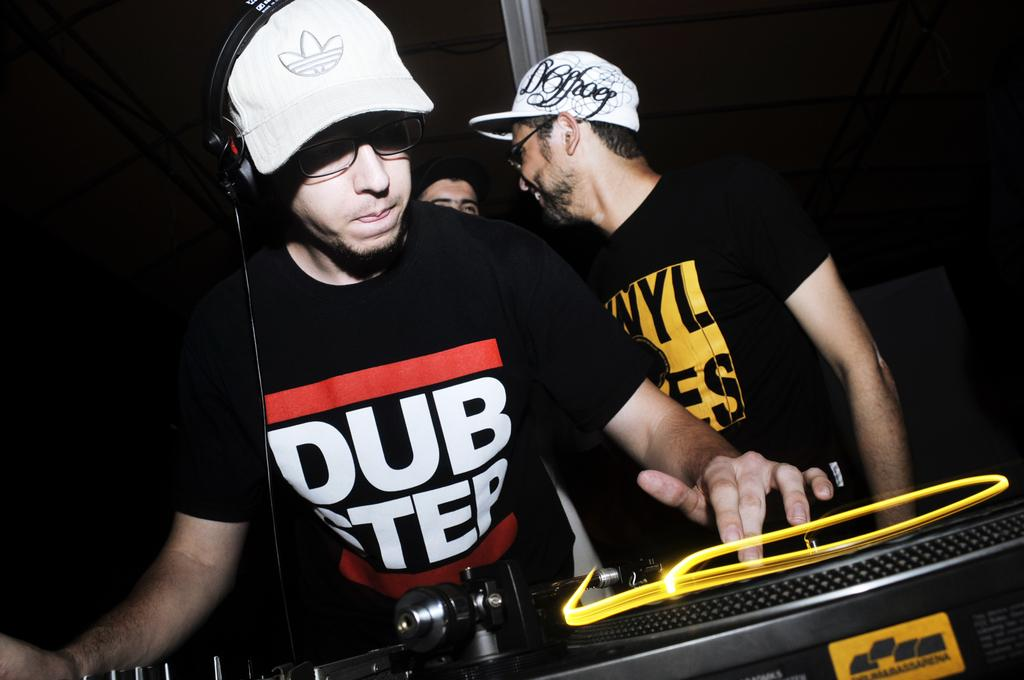Who is the main subject in the image? There is a man in the middle of the image. What is the man wearing? The man is wearing a black t-shirt and a white cap. What is the man doing in the image? The man is playing the role of a DJ. Are there any other people in the image? Yes, there are two other persons in the background of the image. What are the two persons doing? The two persons are standing. What type of company is being discussed by the two persons in the image? There is no discussion or company mentioned in the image; it features a man playing the role of a DJ and two standing persons in the background. 